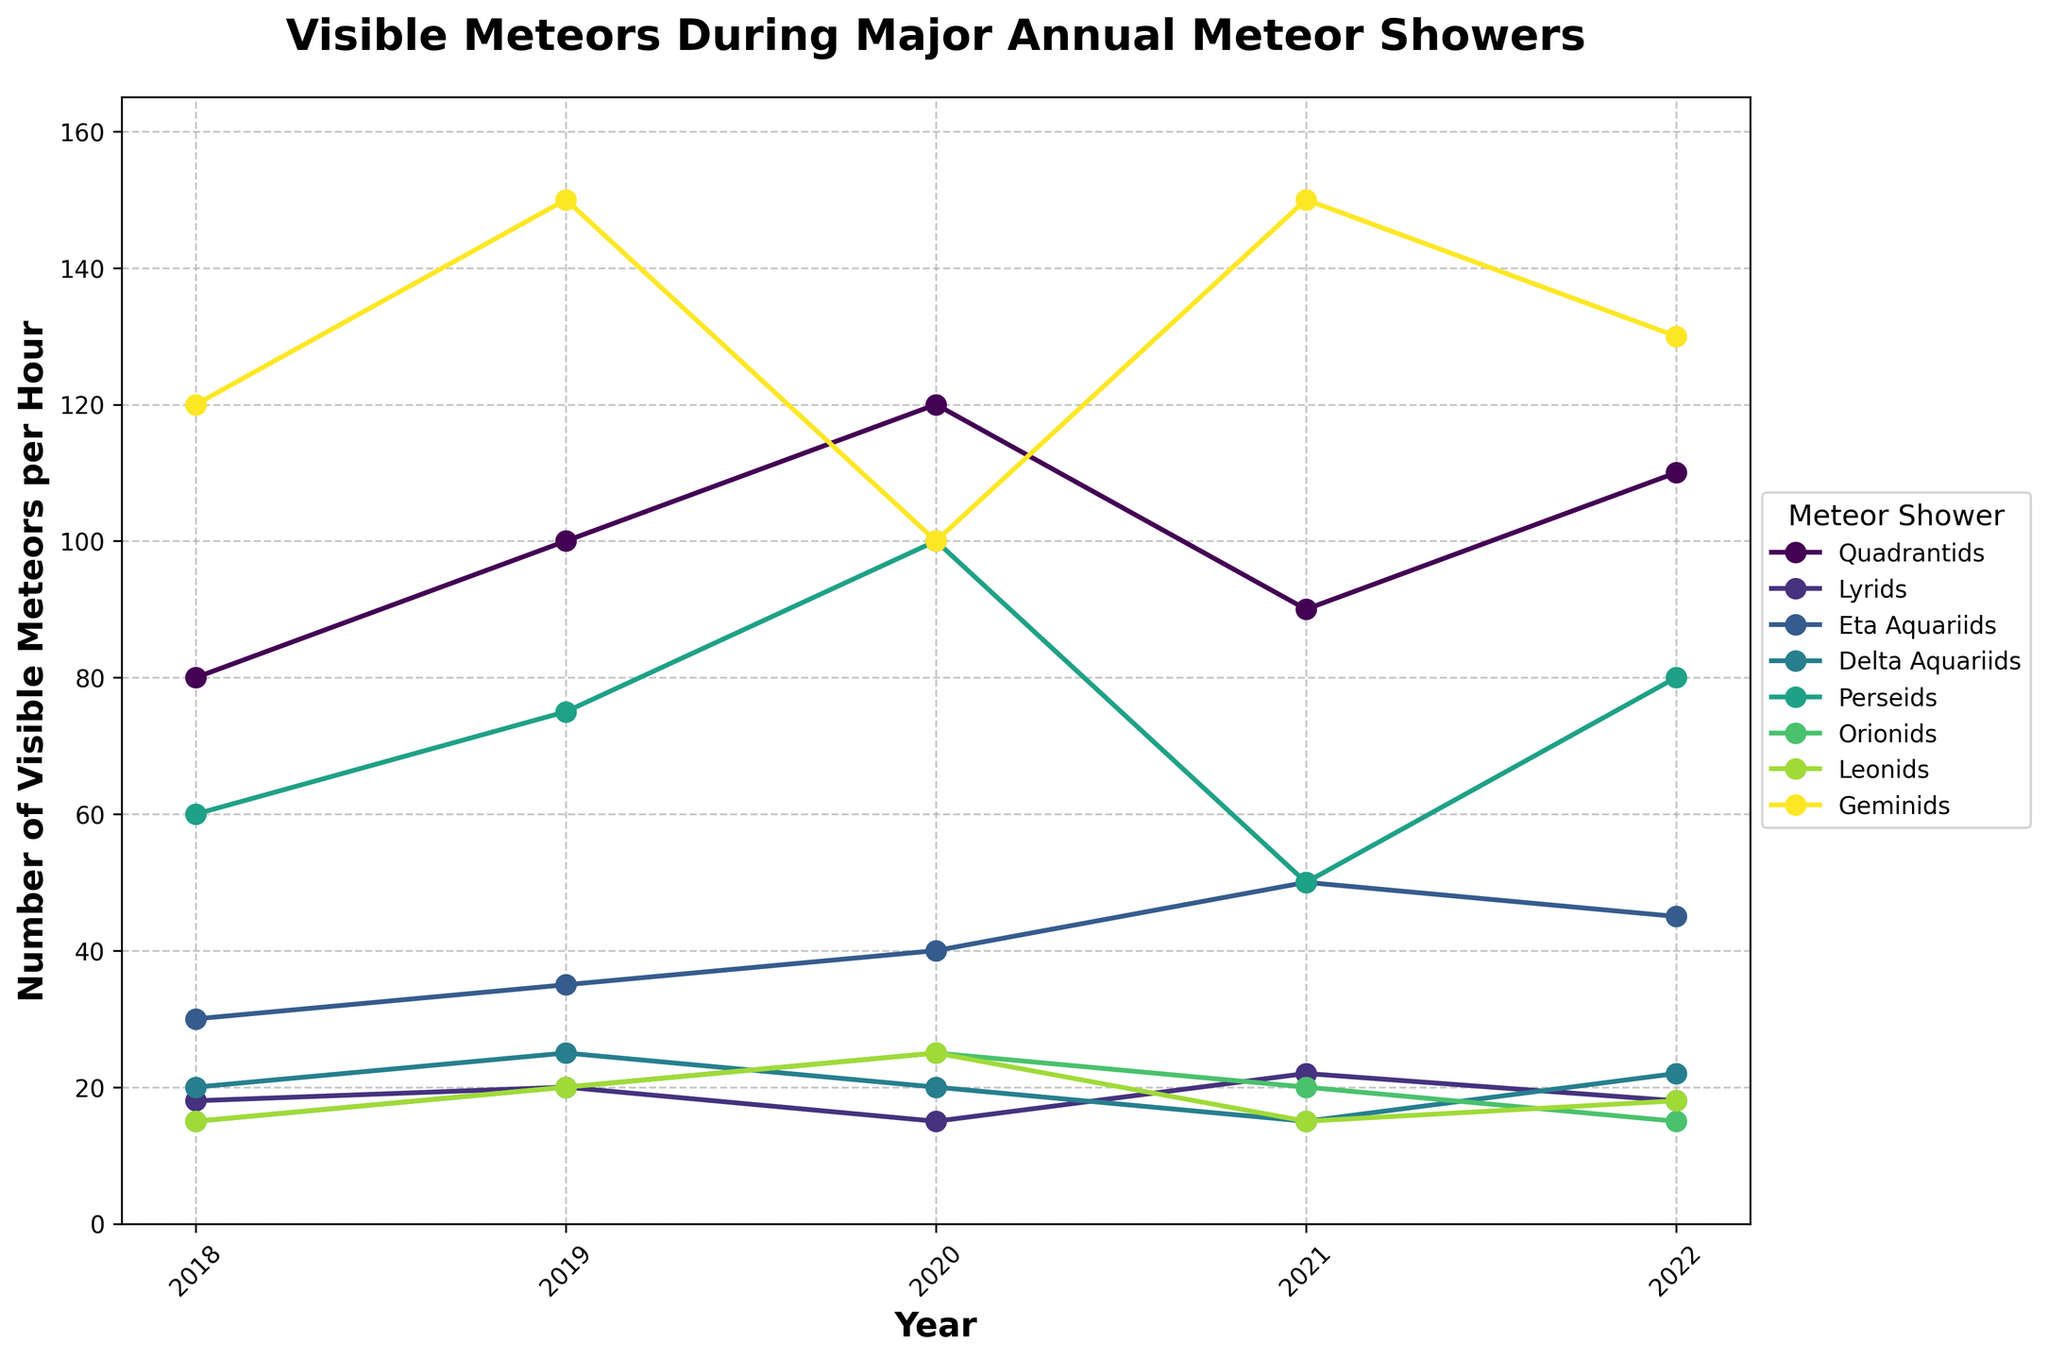What were the number of visible meteors per hour for the Quadrantids in 2018 and 2020? The plot shows that for Quadrantids, the number of visible meteors per hour in 2018 was 80 and in 2020 was 120.
Answer: 80, 120 Which meteor shower had the highest number of visible meteors per hour in 2021? By examining the lines in 2021, the Geminids meteor shower had the highest number of visible meteors per hour, which aligned at 150.
Answer: Geminids Compare the number of visible meteors per hour in 2019 between the Lyrids and Delta Aquariids showers. Which one had more meteors? The Lyrids had 20 visible meteors per hour in 2019 while the Delta Aquariids had 25 visible meteors per hour. Therefore, the Delta Aquariids had more meteors.
Answer: Delta Aquariids Calculate the average number of visible meteors per hour for the Perseids from 2019 to 2021. The values for the Perseids are 75 (2019), 100 (2020), and 50 (2021). The sum is 75 + 100 + 50 = 225. Dividing by 3, the average is 225 / 3 = 75.
Answer: 75 Which meteor shower showed the most significant decrease in visible meteors per hour from 2019 to 2021? By comparing the values, the Perseids decreased from 75 in 2019 to 50 in 2021, a drop of 25 meteors per hour. This is greater than any other decrease shown in the plot over the same period.
Answer: Perseids What color line represents the Geminids meteor shower? By referring to the chart legend, the Geminids meteor shower is represented by a line that typically is shown towards the top as the highest line, colored in the lightest tone available (interpreted as the line standing out at the top instances).
Answer: Lightest color Between 2020 and 2022, which meteor shower had the smallest increase in the number of visible meteors per hour? Looking at the differences over the years 2020 to 2022, the Quadrantids increased by -10, Lyrids by 3, Eta Aquariids by 5, Delta Aquariids by 2, Perseids by -20, Orionids by -10, Leonids by -7, and Geminids by 30. The Delta Aquariids had the smallest increase, increasing by 2 meteors per hour.
Answer: Delta Aquariids Which meteor shower had consistent visibility (least fluctuation) in the number of visible meteors per hour from 2018 to 2022? By examining the lines for consistency with minor fluctuation, the Leonids show the least fluctuation ranging roughly between 15 to 25 meteors per hour from 2018 to 2022.
Answer: Leonids What was the total number of visible meteors per hour observed from the Perseids and the Geminids combined in 2021? In 2021, the Perseids had 50 visible meteors per hour and the Geminids had 150. Combined, this is 50 + 150 = 200.
Answer: 200 